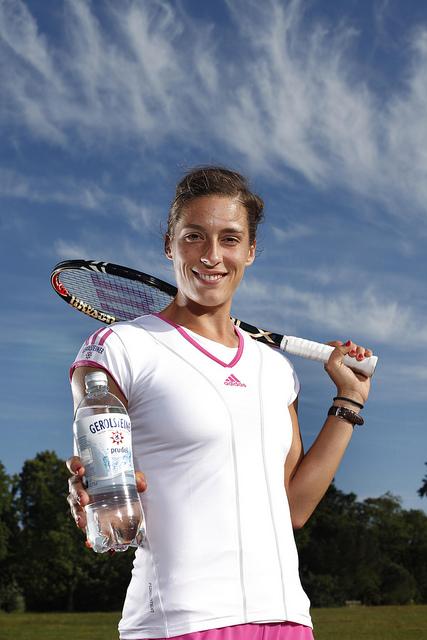What is the boy holding in his hands?
Quick response, please. Tennis racket. Is the girl holding a healthy drink?
Short answer required. Yes. What brand is her shirt?
Give a very brief answer. Adidas. What sport does she play?
Short answer required. Tennis. 